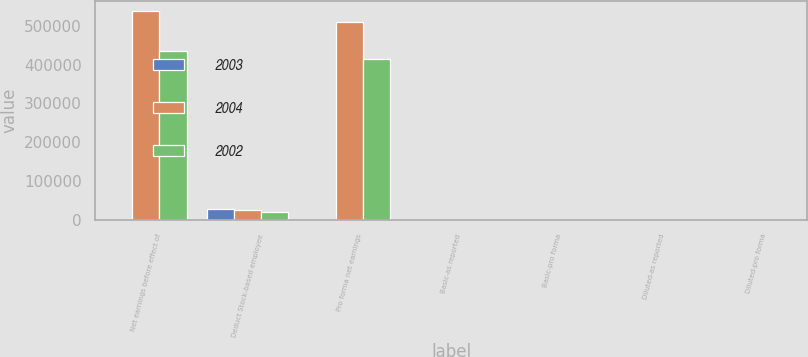Convert chart to OTSL. <chart><loc_0><loc_0><loc_500><loc_500><stacked_bar_chart><ecel><fcel>Net earnings before effect of<fcel>Deduct Stock-based employee<fcel>Pro forma net earnings<fcel>Basic-as reported<fcel>Basic-pro forma<fcel>Diluted-as reported<fcel>Diluted-pro forma<nl><fcel>2003<fcel>2.3<fcel>28487<fcel>2.3<fcel>2.41<fcel>2.32<fcel>2.3<fcel>2.22<nl><fcel>2004<fcel>536834<fcel>26755<fcel>510079<fcel>1.75<fcel>1.66<fcel>1.69<fcel>1.6<nl><fcel>2002<fcel>434141<fcel>20960<fcel>413181<fcel>1.45<fcel>1.38<fcel>1.39<fcel>1.33<nl></chart> 